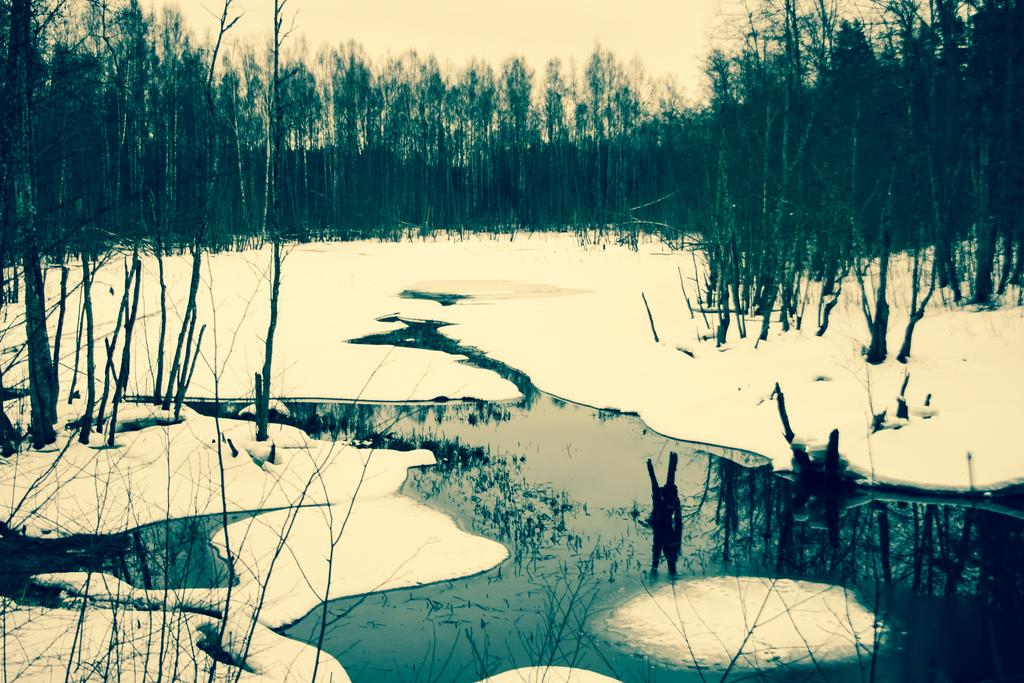What type of weather is depicted in the image? There is snow and water on the ground in the image, which suggests a wintry or wet environment. What type of natural features can be seen in the image? There are trees visible in the image. What is visible in the background of the image? The sky is visible in the background of the image. What type of advertisement can be seen on the trees in the image? There are no advertisements present in the image; only trees, snow, water, and the sky are visible. 